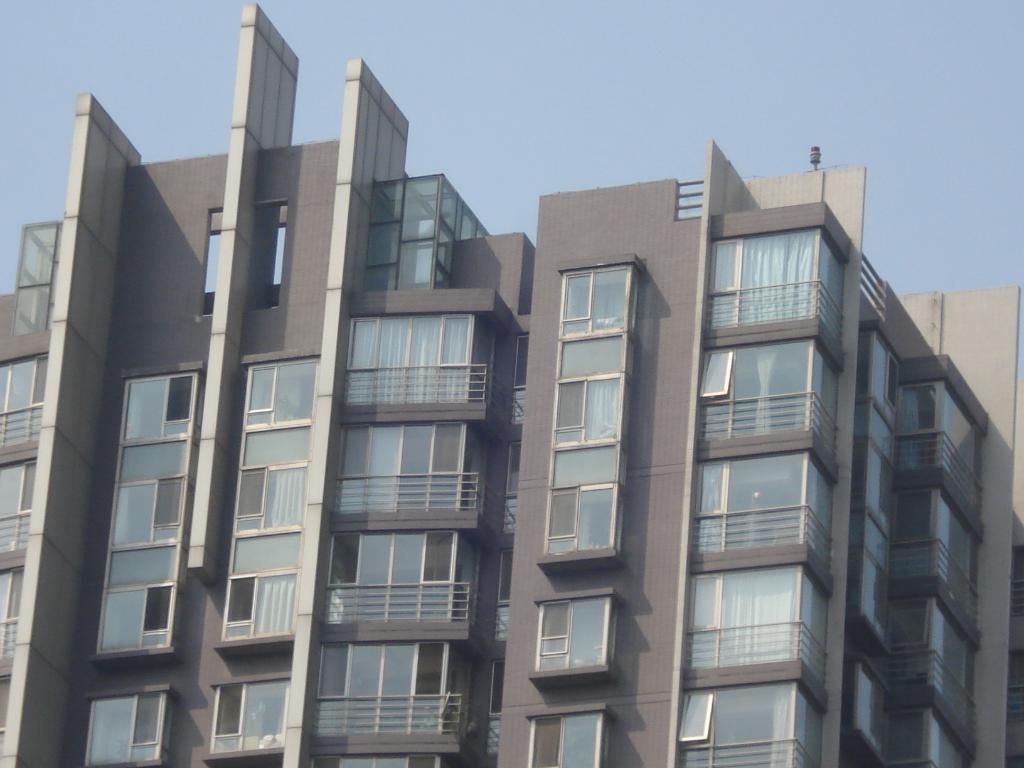Can you describe this image briefly? In this image we can see buildings, windows, curtains, also we can see the sky. 